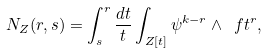<formula> <loc_0><loc_0><loc_500><loc_500>N _ { Z } ( r , s ) = \int _ { s } ^ { r } \frac { d t } { t } \int _ { Z [ t ] } \psi ^ { k - r } \wedge \ f t ^ { r } ,</formula> 